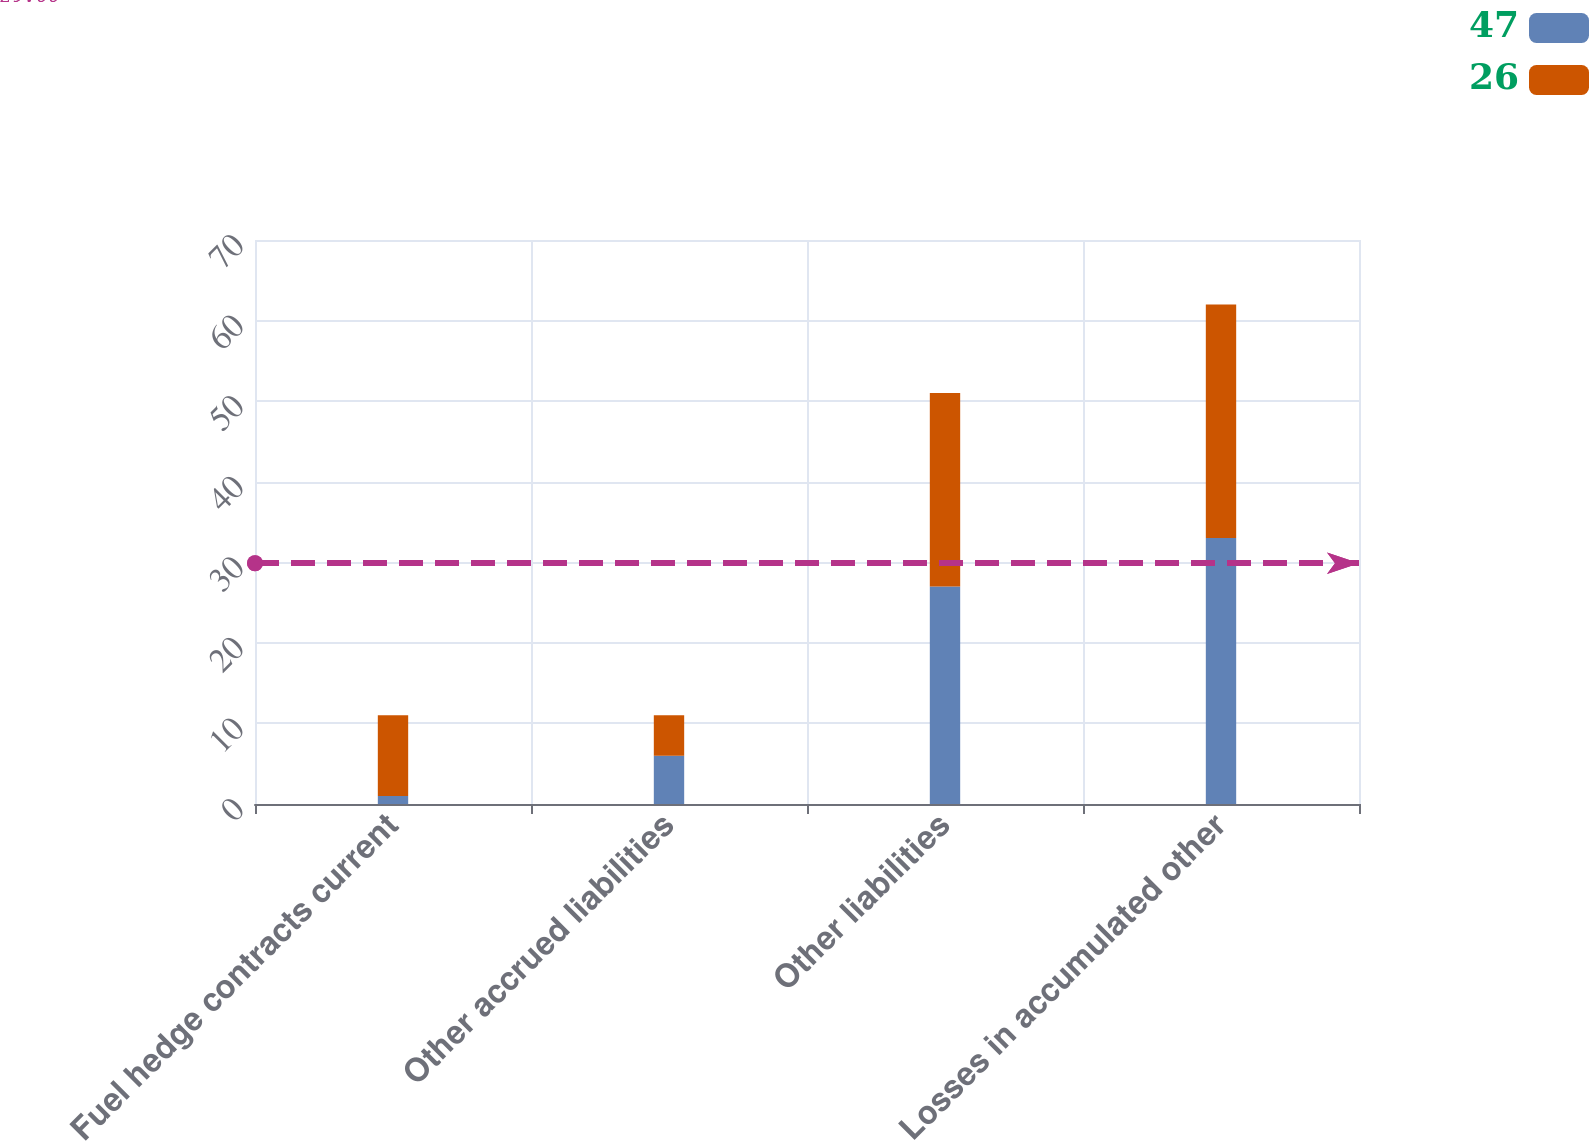<chart> <loc_0><loc_0><loc_500><loc_500><stacked_bar_chart><ecel><fcel>Fuel hedge contracts current<fcel>Other accrued liabilities<fcel>Other liabilities<fcel>Losses in accumulated other<nl><fcel>47<fcel>1<fcel>6<fcel>27<fcel>33<nl><fcel>26<fcel>10<fcel>5<fcel>24<fcel>29<nl></chart> 